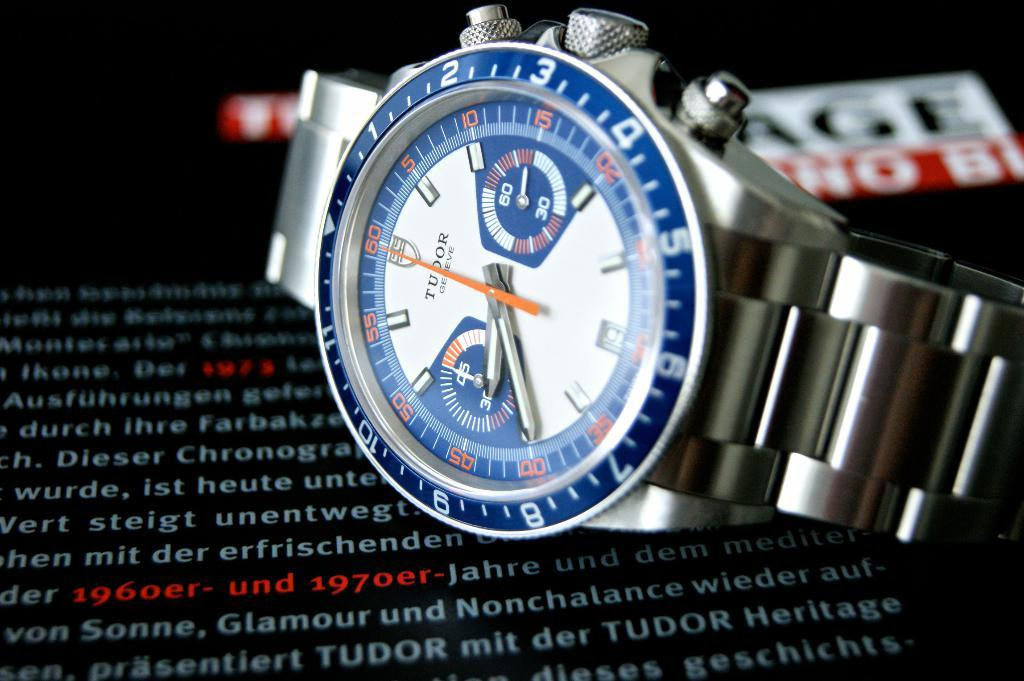<image>
Render a clear and concise summary of the photo. the numbers 1 2 and 3 are on a watch 